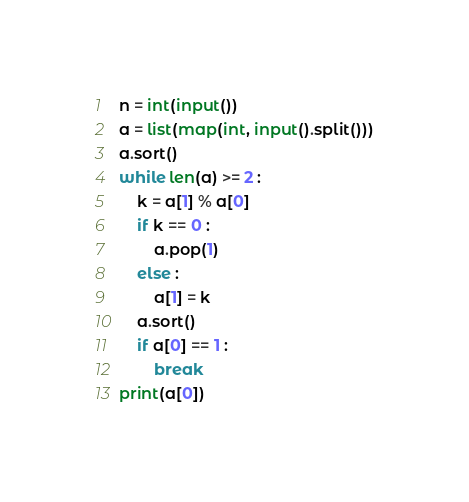<code> <loc_0><loc_0><loc_500><loc_500><_Python_>n = int(input())
a = list(map(int, input().split()))
a.sort()
while len(a) >= 2 :
    k = a[1] % a[0]
    if k == 0 :
        a.pop(1)
    else :
        a[1] = k
    a.sort()
    if a[0] == 1 :
        break
print(a[0])
</code> 